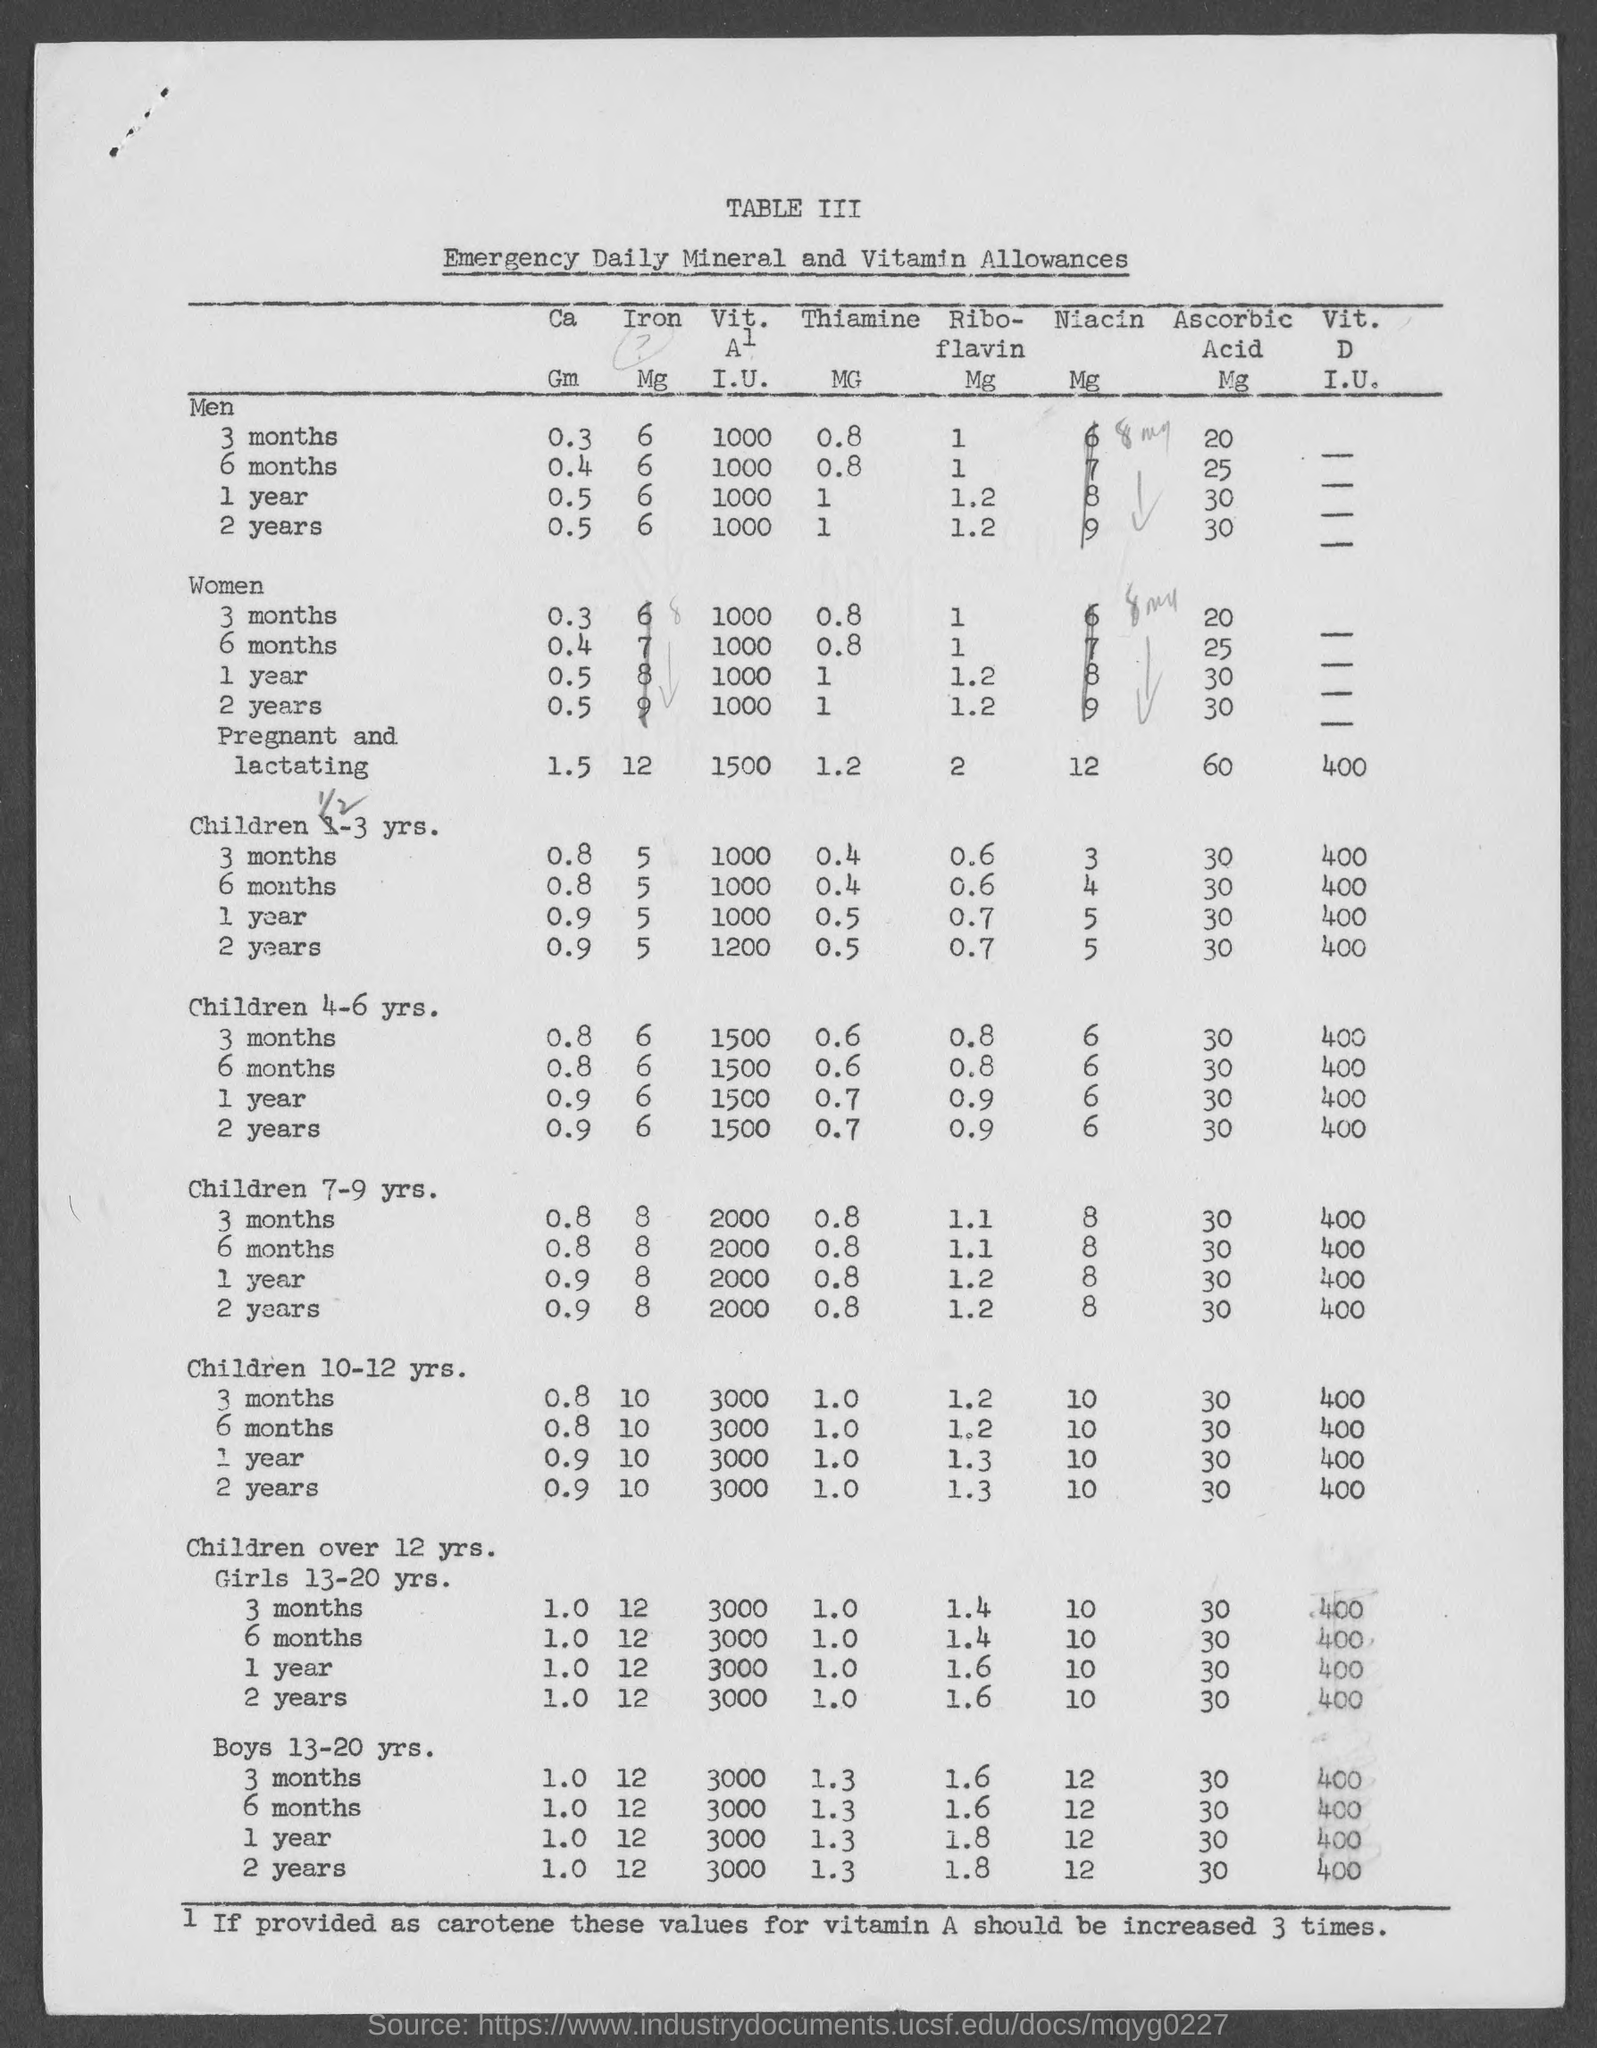Mention a couple of crucial points in this snapshot. What is the table number? III. 